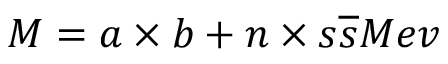<formula> <loc_0><loc_0><loc_500><loc_500>M = a \times b + n \times s \overline { s } M e v</formula> 